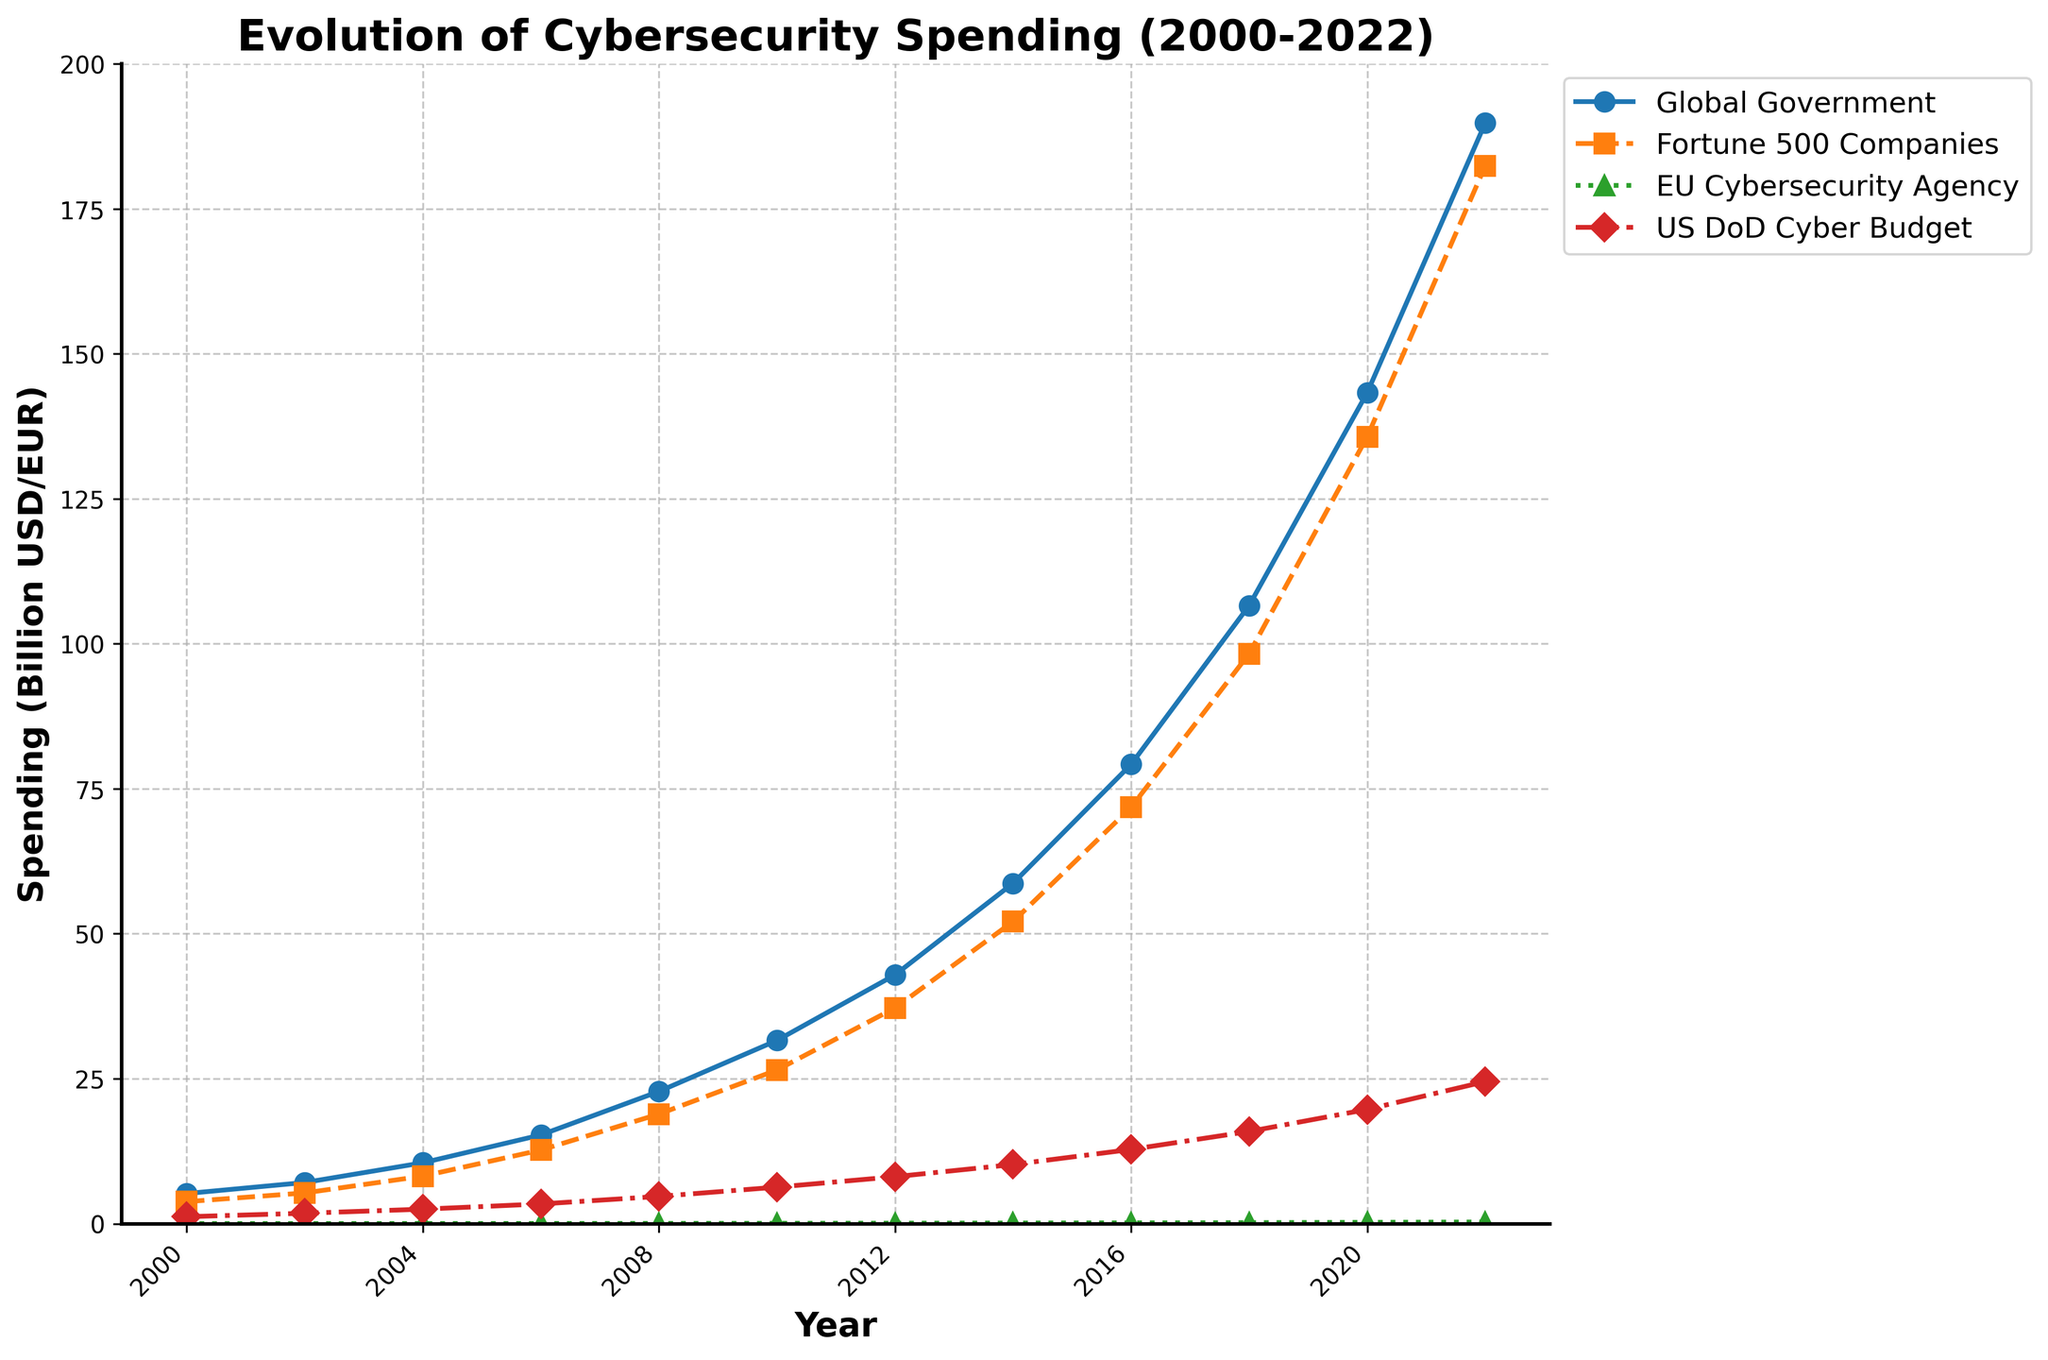What is the trend in global government cybersecurity spending between 2000 and 2022? The global government cybersecurity spending shows an increasing trend from 2000 to 2022. It starts at 5.2 billion USD in 2000 and reaches 189.8 billion USD in 2022, with consistent growth throughout the period.
Answer: Increasing trend How did cybersecurity spending by Fortune 500 companies compare to that by global governments in 2018? In 2018, global government cybersecurity spending was approximately 106.6 billion USD, while Fortune 500 companies spent around 98.3 billion USD. The spending by global governments was higher than that by Fortune 500 companies.
Answer: Global governments Which entity had the smallest increase in cybersecurity budget from 2000 to 2022, the EU Cybersecurity Agency or the US Department of Defense? The EU Cybersecurity Agency budget increased from 12 million EUR in 2000 to 290 million EUR in 2022. The US Department of Defense budget increased from 1.2 billion USD in 2000 to 24.5 billion USD in 2022. Converting EU funds to billion USD (0.012 to 0.29 billion), the increase for the EU Cybersecurity Agency is 0.278 billion, whereas the US DoD increase is 23.3 billion USD. Therefore, the EU Cybersecurity Agency had the smaller increase.
Answer: EU Cybersecurity Agency What is the average cybersecurity spending by Fortune 500 companies from 2000 to 2022? The total spending by Fortune 500 companies from 2000 to 2022 is the sum of 3.8, 5.3, 8.2, 12.7, 18.9, 26.5, 37.2, 52.1, 71.8, 98.3, 135.7, and 182.4 billion USD. The sum is 553.9 billion USD. Dividing by the number of data points (12 years), the average spending is approximately 46.16 billion USD.
Answer: 46.16 billion USD In what year did the US Department of Defense surpass a cybersecurity budget of 10 billion USD? By looking at the US Department of Defense's cybersecurity budget over time, it is clear that the spending surpassed 10 billion USD in the year 2014 when the budget was 10.2 billion USD.
Answer: 2014 Which had a steeper growth rate in cybersecurity spending between 2006 and 2014: global governments or Fortune 500 companies? For global governments, spending grew from 15.3 billion USD in 2006 to 58.7 billion USD in 2014, an increase of 43.4 billion USD. For Fortune 500 companies, spending grew from 12.7 billion USD in 2006 to 52.1 billion USD in 2014, an increase of 39.4 billion USD. Comparing these increments and considering the base amounts in 2006, global governments had a steeper growth rate.
Answer: Global governments How does the EU Cybersecurity Agency's budget in 2008 compare to the US Department of Defense's budget in the same year? In 2008, the EU Cybersecurity Agency's budget was 48 million EUR (0.048 billion USD) and the US Department of Defense's budget was 4.7 billion USD. The US Department of Defense's budget was significantly higher.
Answer: US Department of Defense Which category saw the highest total spending increase from 2000 to 2022? To determine the highest total increase, we need to look at the starting and ending points: Global Government: 189.8 - 5.2 = 184.6 billion USD Fortune 500 Companies: 182.4 - 3.8 = 178.6 billion USD EU Cybersecurity Agency: 0.29 - 0.012 = 0.278 billion EUR (0.278 billion USD) US DoD: 24.5 - 1.2 = 23.3 billion USD The global government category saw the highest total increase.
Answer: Global Government How many years after 2000 did it take for Fortune 500 companies to spend over 100 billion USD on cybersecurity? Fortune 500 companies' spending exceeded 100 billion USD in 2018. From 2000 to 2018 is a span of 18 years.
Answer: 18 years 